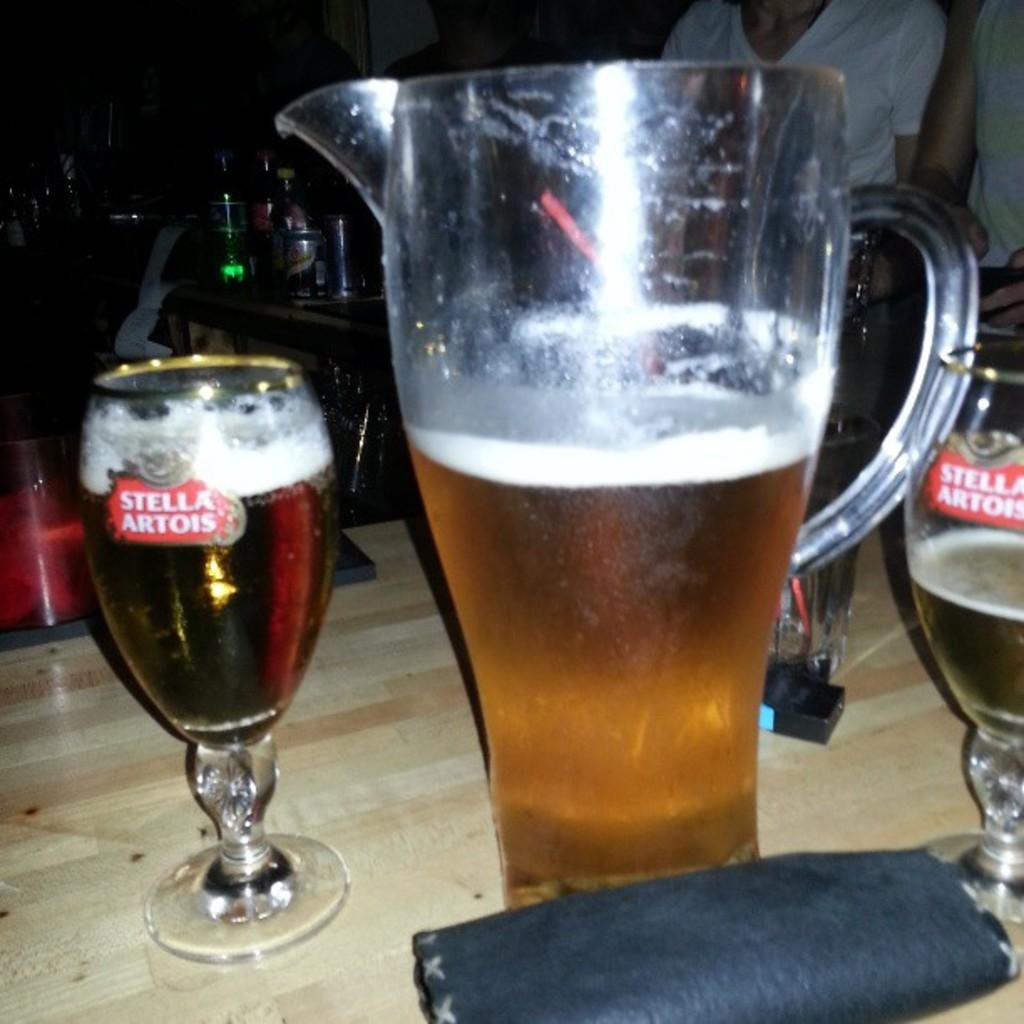<image>
Describe the image concisely. A pitcher of beer has been poured into Stella Artois glasses. 